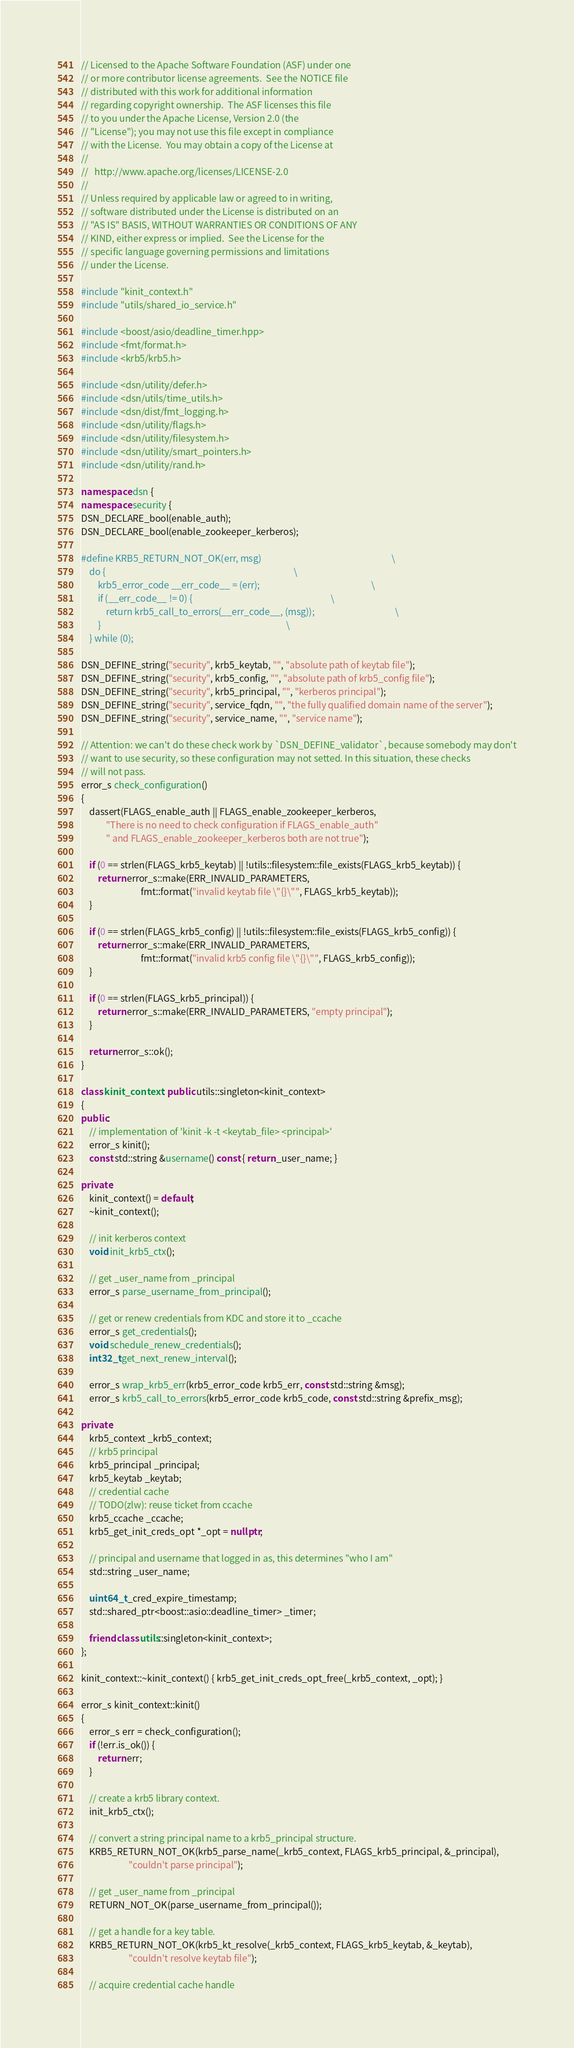Convert code to text. <code><loc_0><loc_0><loc_500><loc_500><_C++_>// Licensed to the Apache Software Foundation (ASF) under one
// or more contributor license agreements.  See the NOTICE file
// distributed with this work for additional information
// regarding copyright ownership.  The ASF licenses this file
// to you under the Apache License, Version 2.0 (the
// "License"); you may not use this file except in compliance
// with the License.  You may obtain a copy of the License at
//
//   http://www.apache.org/licenses/LICENSE-2.0
//
// Unless required by applicable law or agreed to in writing,
// software distributed under the License is distributed on an
// "AS IS" BASIS, WITHOUT WARRANTIES OR CONDITIONS OF ANY
// KIND, either express or implied.  See the License for the
// specific language governing permissions and limitations
// under the License.

#include "kinit_context.h"
#include "utils/shared_io_service.h"

#include <boost/asio/deadline_timer.hpp>
#include <fmt/format.h>
#include <krb5/krb5.h>

#include <dsn/utility/defer.h>
#include <dsn/utils/time_utils.h>
#include <dsn/dist/fmt_logging.h>
#include <dsn/utility/flags.h>
#include <dsn/utility/filesystem.h>
#include <dsn/utility/smart_pointers.h>
#include <dsn/utility/rand.h>

namespace dsn {
namespace security {
DSN_DECLARE_bool(enable_auth);
DSN_DECLARE_bool(enable_zookeeper_kerberos);

#define KRB5_RETURN_NOT_OK(err, msg)                                                               \
    do {                                                                                           \
        krb5_error_code __err_code__ = (err);                                                      \
        if (__err_code__ != 0) {                                                                   \
            return krb5_call_to_errors(__err_code__, (msg));                                       \
        }                                                                                          \
    } while (0);

DSN_DEFINE_string("security", krb5_keytab, "", "absolute path of keytab file");
DSN_DEFINE_string("security", krb5_config, "", "absolute path of krb5_config file");
DSN_DEFINE_string("security", krb5_principal, "", "kerberos principal");
DSN_DEFINE_string("security", service_fqdn, "", "the fully qualified domain name of the server");
DSN_DEFINE_string("security", service_name, "", "service name");

// Attention: we can't do these check work by `DSN_DEFINE_validator`, because somebody may don't
// want to use security, so these configuration may not setted. In this situation, these checks
// will not pass.
error_s check_configuration()
{
    dassert(FLAGS_enable_auth || FLAGS_enable_zookeeper_kerberos,
            "There is no need to check configuration if FLAGS_enable_auth"
            " and FLAGS_enable_zookeeper_kerberos both are not true");

    if (0 == strlen(FLAGS_krb5_keytab) || !utils::filesystem::file_exists(FLAGS_krb5_keytab)) {
        return error_s::make(ERR_INVALID_PARAMETERS,
                             fmt::format("invalid keytab file \"{}\"", FLAGS_krb5_keytab));
    }

    if (0 == strlen(FLAGS_krb5_config) || !utils::filesystem::file_exists(FLAGS_krb5_config)) {
        return error_s::make(ERR_INVALID_PARAMETERS,
                             fmt::format("invalid krb5 config file \"{}\"", FLAGS_krb5_config));
    }

    if (0 == strlen(FLAGS_krb5_principal)) {
        return error_s::make(ERR_INVALID_PARAMETERS, "empty principal");
    }

    return error_s::ok();
}

class kinit_context : public utils::singleton<kinit_context>
{
public:
    // implementation of 'kinit -k -t <keytab_file> <principal>'
    error_s kinit();
    const std::string &username() const { return _user_name; }

private:
    kinit_context() = default;
    ~kinit_context();

    // init kerberos context
    void init_krb5_ctx();

    // get _user_name from _principal
    error_s parse_username_from_principal();

    // get or renew credentials from KDC and store it to _ccache
    error_s get_credentials();
    void schedule_renew_credentials();
    int32_t get_next_renew_interval();

    error_s wrap_krb5_err(krb5_error_code krb5_err, const std::string &msg);
    error_s krb5_call_to_errors(krb5_error_code krb5_code, const std::string &prefix_msg);

private:
    krb5_context _krb5_context;
    // krb5 principal
    krb5_principal _principal;
    krb5_keytab _keytab;
    // credential cache
    // TODO(zlw): reuse ticket from ccache
    krb5_ccache _ccache;
    krb5_get_init_creds_opt *_opt = nullptr;

    // principal and username that logged in as, this determines "who I am"
    std::string _user_name;

    uint64_t _cred_expire_timestamp;
    std::shared_ptr<boost::asio::deadline_timer> _timer;

    friend class utils::singleton<kinit_context>;
};

kinit_context::~kinit_context() { krb5_get_init_creds_opt_free(_krb5_context, _opt); }

error_s kinit_context::kinit()
{
    error_s err = check_configuration();
    if (!err.is_ok()) {
        return err;
    }

    // create a krb5 library context.
    init_krb5_ctx();

    // convert a string principal name to a krb5_principal structure.
    KRB5_RETURN_NOT_OK(krb5_parse_name(_krb5_context, FLAGS_krb5_principal, &_principal),
                       "couldn't parse principal");

    // get _user_name from _principal
    RETURN_NOT_OK(parse_username_from_principal());

    // get a handle for a key table.
    KRB5_RETURN_NOT_OK(krb5_kt_resolve(_krb5_context, FLAGS_krb5_keytab, &_keytab),
                       "couldn't resolve keytab file");

    // acquire credential cache handle</code> 